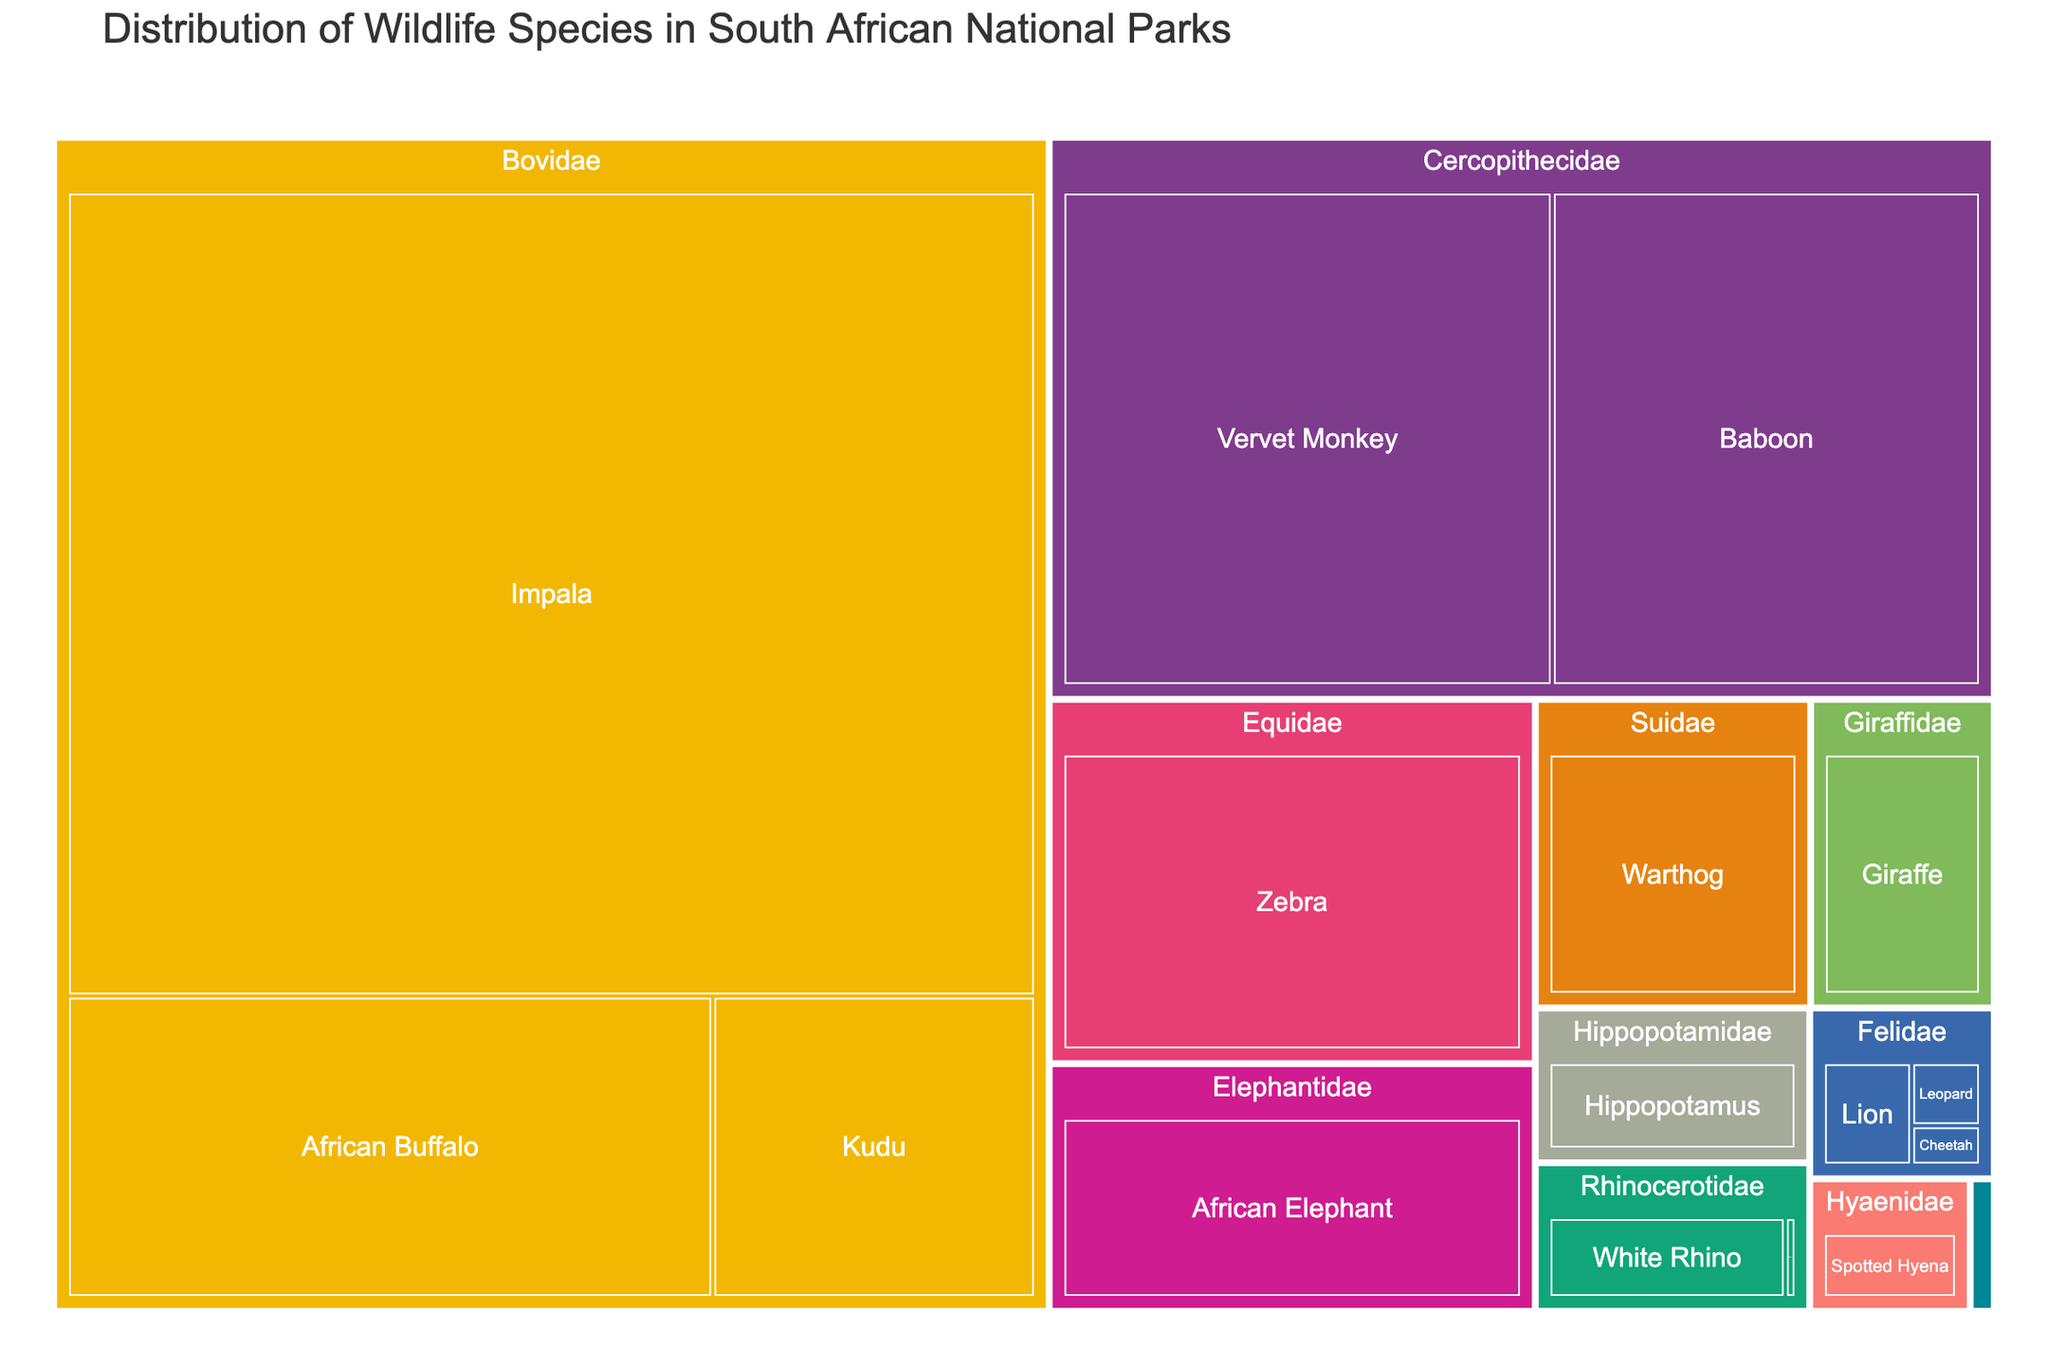Which family has the highest population of wildlife species? The family with the highest population of wildlife species is identified by looking for the group with the largest combined area in the treemap.
Answer: Bovidae How many species are part of the Felidae family? Count the individual squares within the Felidae section of the treemap to determine the number of species.
Answer: 3 Which species under the Rhinocerotidae family has a larger population, the White Rhino or the Black Rhino? Compare the areas representing the White Rhino and Black Rhino within the Rhinocerotidae section. The larger area indicates the species with the higher population.
Answer: White Rhino What is the total population of species under the Giraffidae and Hippopotamidae families combined? Add the population of Giraffe (8000) and Hippopotamus (6000).
Answer: 14000 Which animal species has the smallest population in the treemap? Look for the smallest square in the treemap, which represents the species with the smallest population.
Answer: Black Rhino How does the population of African Elephants compare to that of Zebras? Compare the areas of the African Elephant and Zebra sections; the larger area represents the species with the higher population.
Answer: Zebras have a larger population than African Elephants Which family has a higher population, Equidae or Suidae? Compare the combined areas of all species within the Equidae and Suidae families to see which group is larger.
Answer: Equidae What percentage of the total population does the African Buffalo represent within the Bovidae family? Calculate the percentage by dividing the African Buffalo population (30000) by the total Bovidae population (165000: 30000+15000+120000) and multiplying by 100.
Answer: Approximately 18.18% Which species has a population closest to 10000? Find the species whose area corresponds closest to a population of around 10000.
Answer: Warthog What is the difference in population between the Spotted Hyena and the Cheetah? Subtract the population of the Cheetah (750) from the population of the Spotted Hyena (3000).
Answer: 2250 